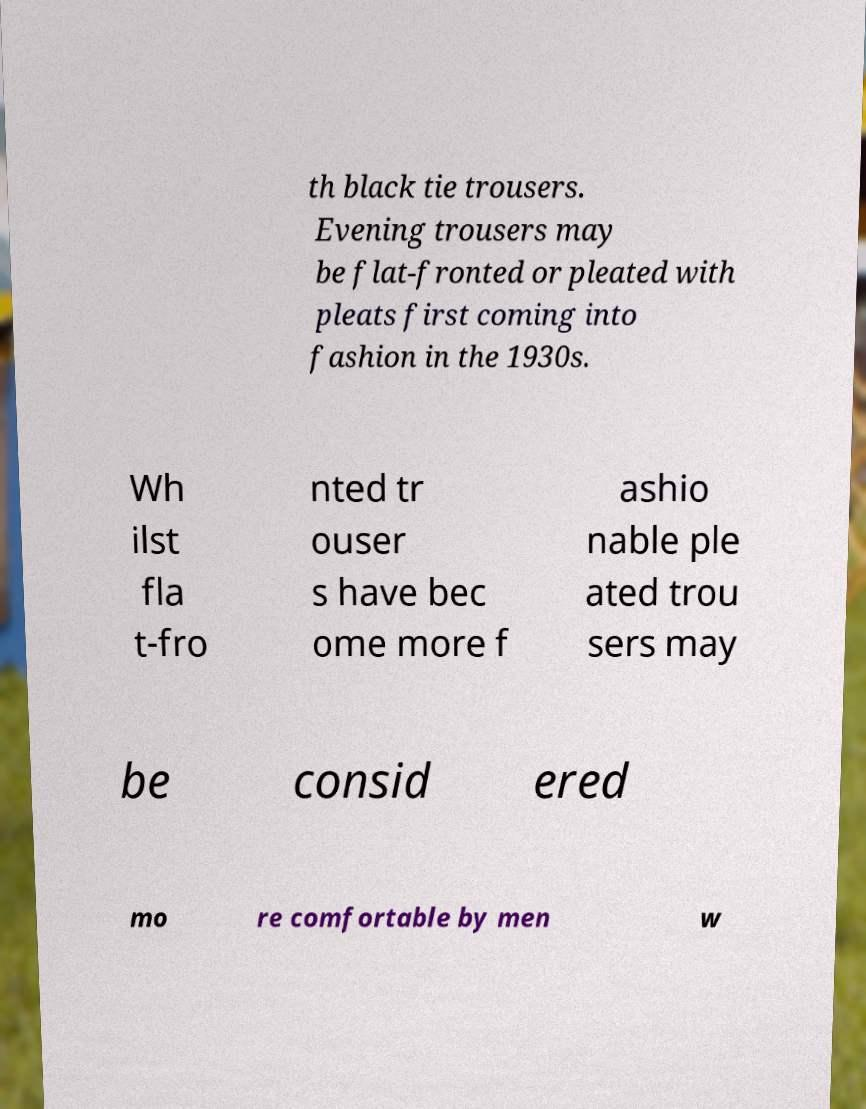I need the written content from this picture converted into text. Can you do that? th black tie trousers. Evening trousers may be flat-fronted or pleated with pleats first coming into fashion in the 1930s. Wh ilst fla t-fro nted tr ouser s have bec ome more f ashio nable ple ated trou sers may be consid ered mo re comfortable by men w 